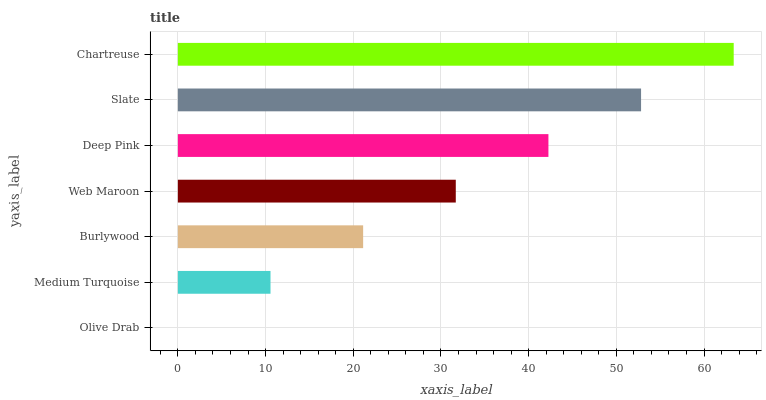Is Olive Drab the minimum?
Answer yes or no. Yes. Is Chartreuse the maximum?
Answer yes or no. Yes. Is Medium Turquoise the minimum?
Answer yes or no. No. Is Medium Turquoise the maximum?
Answer yes or no. No. Is Medium Turquoise greater than Olive Drab?
Answer yes or no. Yes. Is Olive Drab less than Medium Turquoise?
Answer yes or no. Yes. Is Olive Drab greater than Medium Turquoise?
Answer yes or no. No. Is Medium Turquoise less than Olive Drab?
Answer yes or no. No. Is Web Maroon the high median?
Answer yes or no. Yes. Is Web Maroon the low median?
Answer yes or no. Yes. Is Slate the high median?
Answer yes or no. No. Is Burlywood the low median?
Answer yes or no. No. 